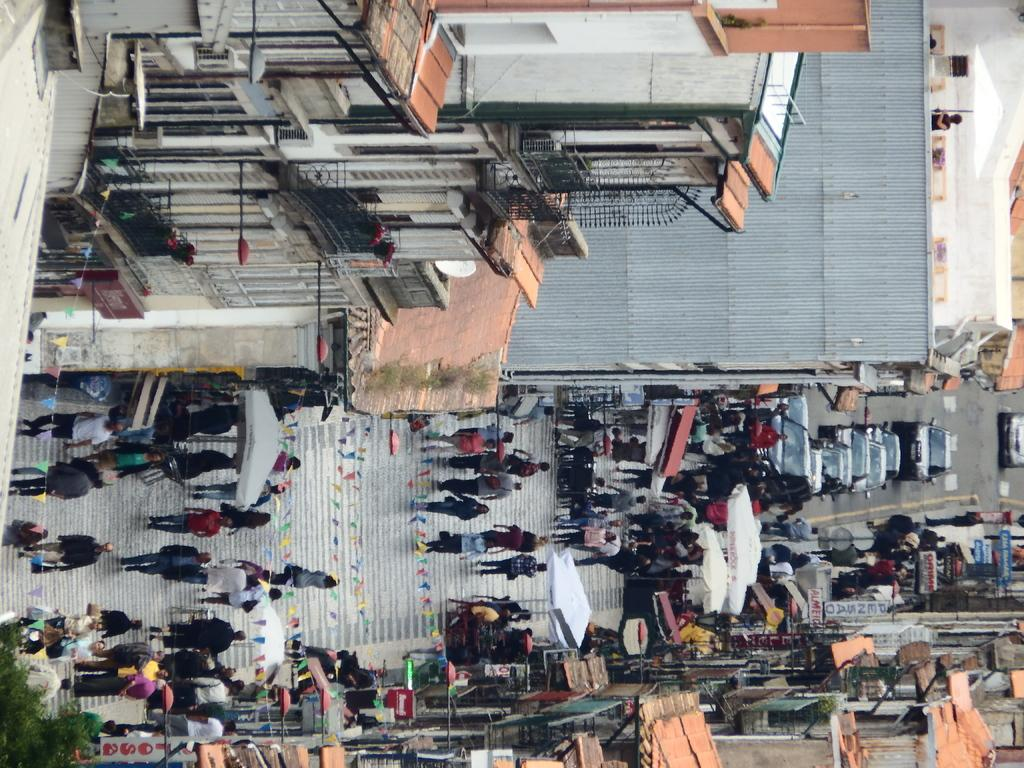Who or what can be seen in the image? There are people in the image. What else is visible on the road in the image? There are vehicles on the road in the image. What objects are being used to protect against the weather in the image? Umbrellas are visible in the image. What type of decorative or symbolic objects are present in the image? Flags are present in the image. What are the boards used for in the image? Boards are present in the image, but their purpose is not clear from the facts provided. What type of structures can be seen in the image? Buildings are visible in the image. What type of vegetation is present in the bottom left side of the image? Leaves are present in the bottom left side of the image. What type of rock is being used to rate the lead content in the image? There is no rock or lead content present in the image. How does the lead affect the rate of the rock in the image? There is no rock or lead content present in the image, so this question cannot be answered. 